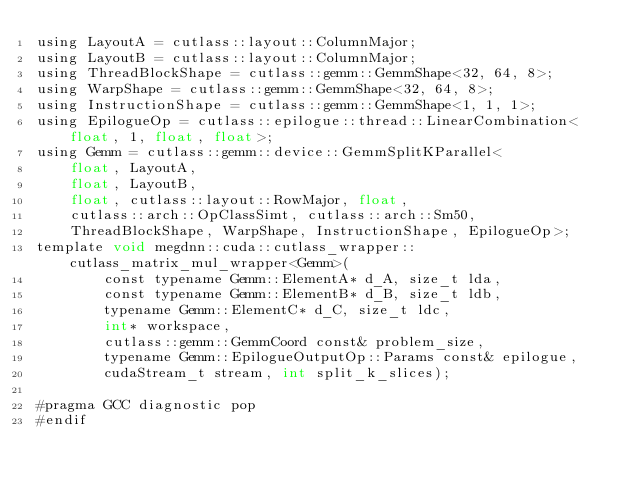Convert code to text. <code><loc_0><loc_0><loc_500><loc_500><_Cuda_>using LayoutA = cutlass::layout::ColumnMajor;
using LayoutB = cutlass::layout::ColumnMajor;
using ThreadBlockShape = cutlass::gemm::GemmShape<32, 64, 8>;
using WarpShape = cutlass::gemm::GemmShape<32, 64, 8>;
using InstructionShape = cutlass::gemm::GemmShape<1, 1, 1>;
using EpilogueOp = cutlass::epilogue::thread::LinearCombination<float, 1, float, float>;
using Gemm = cutlass::gemm::device::GemmSplitKParallel<
    float, LayoutA, 
    float, LayoutB, 
    float, cutlass::layout::RowMajor, float, 
    cutlass::arch::OpClassSimt, cutlass::arch::Sm50, 
    ThreadBlockShape, WarpShape, InstructionShape, EpilogueOp>;
template void megdnn::cuda::cutlass_wrapper::cutlass_matrix_mul_wrapper<Gemm>(
        const typename Gemm::ElementA* d_A, size_t lda, 
        const typename Gemm::ElementB* d_B, size_t ldb,  
        typename Gemm::ElementC* d_C, size_t ldc,  
        int* workspace, 
        cutlass::gemm::GemmCoord const& problem_size,   
        typename Gemm::EpilogueOutputOp::Params const& epilogue, 
        cudaStream_t stream, int split_k_slices);

#pragma GCC diagnostic pop
#endif
</code> 